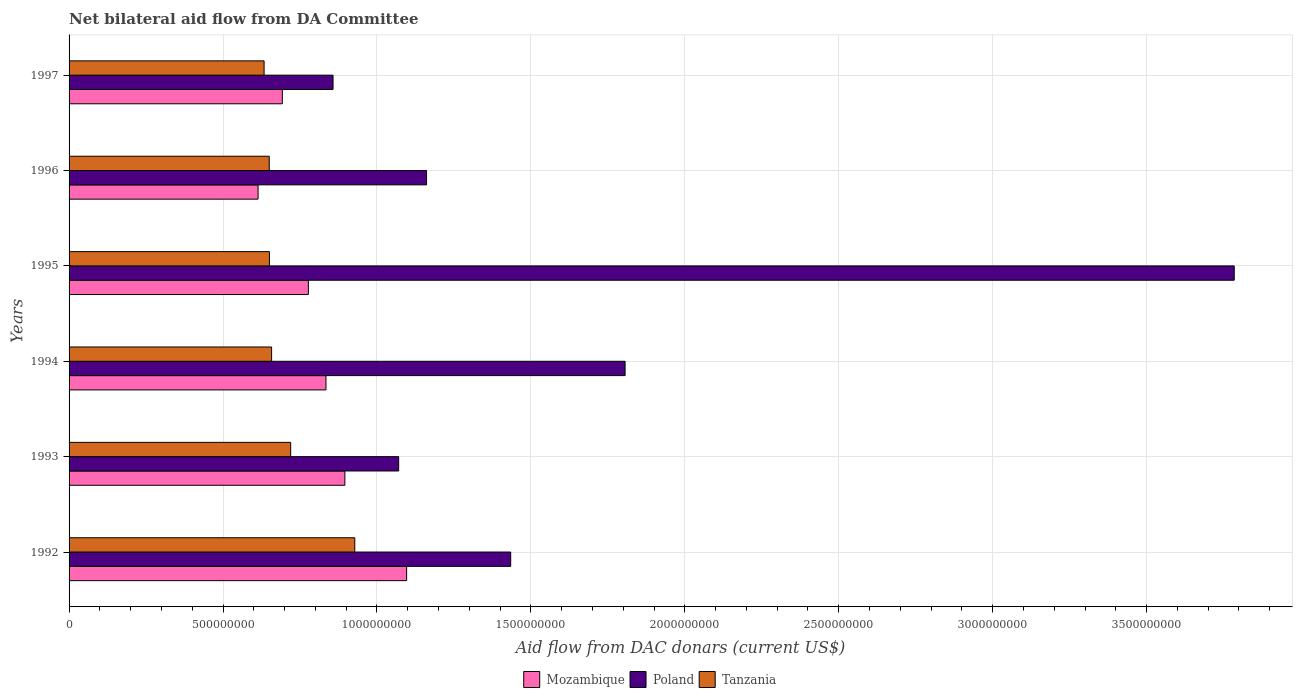Are the number of bars on each tick of the Y-axis equal?
Your answer should be very brief. Yes. How many bars are there on the 6th tick from the top?
Offer a very short reply. 3. What is the aid flow in in Mozambique in 1993?
Your answer should be compact. 8.96e+08. Across all years, what is the maximum aid flow in in Tanzania?
Your answer should be compact. 9.28e+08. Across all years, what is the minimum aid flow in in Mozambique?
Give a very brief answer. 6.14e+08. What is the total aid flow in in Tanzania in the graph?
Offer a very short reply. 4.24e+09. What is the difference between the aid flow in in Poland in 1993 and that in 1996?
Provide a short and direct response. -9.06e+07. What is the difference between the aid flow in in Tanzania in 1996 and the aid flow in in Poland in 1997?
Provide a succinct answer. -2.07e+08. What is the average aid flow in in Tanzania per year?
Keep it short and to the point. 7.07e+08. In the year 1996, what is the difference between the aid flow in in Mozambique and aid flow in in Poland?
Offer a very short reply. -5.47e+08. What is the ratio of the aid flow in in Mozambique in 1992 to that in 1996?
Your response must be concise. 1.79. Is the aid flow in in Mozambique in 1992 less than that in 1995?
Your response must be concise. No. Is the difference between the aid flow in in Mozambique in 1993 and 1995 greater than the difference between the aid flow in in Poland in 1993 and 1995?
Your answer should be compact. Yes. What is the difference between the highest and the second highest aid flow in in Tanzania?
Give a very brief answer. 2.08e+08. What is the difference between the highest and the lowest aid flow in in Mozambique?
Ensure brevity in your answer.  4.83e+08. Is the sum of the aid flow in in Mozambique in 1994 and 1996 greater than the maximum aid flow in in Tanzania across all years?
Offer a very short reply. Yes. What does the 1st bar from the bottom in 1994 represents?
Your answer should be very brief. Mozambique. Is it the case that in every year, the sum of the aid flow in in Mozambique and aid flow in in Tanzania is greater than the aid flow in in Poland?
Your answer should be compact. No. Are all the bars in the graph horizontal?
Make the answer very short. Yes. What is the difference between two consecutive major ticks on the X-axis?
Your response must be concise. 5.00e+08. Are the values on the major ticks of X-axis written in scientific E-notation?
Provide a short and direct response. No. Does the graph contain any zero values?
Make the answer very short. No. Does the graph contain grids?
Offer a very short reply. Yes. How are the legend labels stacked?
Give a very brief answer. Horizontal. What is the title of the graph?
Your answer should be compact. Net bilateral aid flow from DA Committee. Does "Kuwait" appear as one of the legend labels in the graph?
Your answer should be very brief. No. What is the label or title of the X-axis?
Provide a short and direct response. Aid flow from DAC donars (current US$). What is the Aid flow from DAC donars (current US$) in Mozambique in 1992?
Offer a terse response. 1.10e+09. What is the Aid flow from DAC donars (current US$) in Poland in 1992?
Give a very brief answer. 1.43e+09. What is the Aid flow from DAC donars (current US$) of Tanzania in 1992?
Offer a terse response. 9.28e+08. What is the Aid flow from DAC donars (current US$) in Mozambique in 1993?
Offer a very short reply. 8.96e+08. What is the Aid flow from DAC donars (current US$) of Poland in 1993?
Give a very brief answer. 1.07e+09. What is the Aid flow from DAC donars (current US$) in Tanzania in 1993?
Keep it short and to the point. 7.20e+08. What is the Aid flow from DAC donars (current US$) in Mozambique in 1994?
Ensure brevity in your answer.  8.34e+08. What is the Aid flow from DAC donars (current US$) in Poland in 1994?
Your answer should be compact. 1.81e+09. What is the Aid flow from DAC donars (current US$) in Tanzania in 1994?
Give a very brief answer. 6.58e+08. What is the Aid flow from DAC donars (current US$) in Mozambique in 1995?
Ensure brevity in your answer.  7.77e+08. What is the Aid flow from DAC donars (current US$) in Poland in 1995?
Your answer should be compact. 3.78e+09. What is the Aid flow from DAC donars (current US$) in Tanzania in 1995?
Provide a short and direct response. 6.51e+08. What is the Aid flow from DAC donars (current US$) in Mozambique in 1996?
Offer a very short reply. 6.14e+08. What is the Aid flow from DAC donars (current US$) of Poland in 1996?
Your response must be concise. 1.16e+09. What is the Aid flow from DAC donars (current US$) in Tanzania in 1996?
Keep it short and to the point. 6.50e+08. What is the Aid flow from DAC donars (current US$) in Mozambique in 1997?
Your response must be concise. 6.93e+08. What is the Aid flow from DAC donars (current US$) in Poland in 1997?
Offer a terse response. 8.57e+08. What is the Aid flow from DAC donars (current US$) of Tanzania in 1997?
Your answer should be very brief. 6.33e+08. Across all years, what is the maximum Aid flow from DAC donars (current US$) of Mozambique?
Make the answer very short. 1.10e+09. Across all years, what is the maximum Aid flow from DAC donars (current US$) of Poland?
Give a very brief answer. 3.78e+09. Across all years, what is the maximum Aid flow from DAC donars (current US$) in Tanzania?
Give a very brief answer. 9.28e+08. Across all years, what is the minimum Aid flow from DAC donars (current US$) of Mozambique?
Ensure brevity in your answer.  6.14e+08. Across all years, what is the minimum Aid flow from DAC donars (current US$) in Poland?
Make the answer very short. 8.57e+08. Across all years, what is the minimum Aid flow from DAC donars (current US$) of Tanzania?
Ensure brevity in your answer.  6.33e+08. What is the total Aid flow from DAC donars (current US$) of Mozambique in the graph?
Give a very brief answer. 4.91e+09. What is the total Aid flow from DAC donars (current US$) of Poland in the graph?
Your answer should be compact. 1.01e+1. What is the total Aid flow from DAC donars (current US$) in Tanzania in the graph?
Offer a terse response. 4.24e+09. What is the difference between the Aid flow from DAC donars (current US$) of Mozambique in 1992 and that in 1993?
Your response must be concise. 2.01e+08. What is the difference between the Aid flow from DAC donars (current US$) in Poland in 1992 and that in 1993?
Provide a succinct answer. 3.64e+08. What is the difference between the Aid flow from DAC donars (current US$) in Tanzania in 1992 and that in 1993?
Your answer should be compact. 2.08e+08. What is the difference between the Aid flow from DAC donars (current US$) of Mozambique in 1992 and that in 1994?
Your answer should be compact. 2.62e+08. What is the difference between the Aid flow from DAC donars (current US$) of Poland in 1992 and that in 1994?
Your answer should be very brief. -3.72e+08. What is the difference between the Aid flow from DAC donars (current US$) of Tanzania in 1992 and that in 1994?
Your answer should be very brief. 2.70e+08. What is the difference between the Aid flow from DAC donars (current US$) of Mozambique in 1992 and that in 1995?
Keep it short and to the point. 3.19e+08. What is the difference between the Aid flow from DAC donars (current US$) of Poland in 1992 and that in 1995?
Your response must be concise. -2.35e+09. What is the difference between the Aid flow from DAC donars (current US$) of Tanzania in 1992 and that in 1995?
Give a very brief answer. 2.77e+08. What is the difference between the Aid flow from DAC donars (current US$) in Mozambique in 1992 and that in 1996?
Your response must be concise. 4.83e+08. What is the difference between the Aid flow from DAC donars (current US$) in Poland in 1992 and that in 1996?
Provide a short and direct response. 2.73e+08. What is the difference between the Aid flow from DAC donars (current US$) of Tanzania in 1992 and that in 1996?
Your response must be concise. 2.78e+08. What is the difference between the Aid flow from DAC donars (current US$) in Mozambique in 1992 and that in 1997?
Give a very brief answer. 4.04e+08. What is the difference between the Aid flow from DAC donars (current US$) in Poland in 1992 and that in 1997?
Make the answer very short. 5.77e+08. What is the difference between the Aid flow from DAC donars (current US$) in Tanzania in 1992 and that in 1997?
Make the answer very short. 2.95e+08. What is the difference between the Aid flow from DAC donars (current US$) in Mozambique in 1993 and that in 1994?
Ensure brevity in your answer.  6.14e+07. What is the difference between the Aid flow from DAC donars (current US$) of Poland in 1993 and that in 1994?
Offer a terse response. -7.36e+08. What is the difference between the Aid flow from DAC donars (current US$) of Tanzania in 1993 and that in 1994?
Keep it short and to the point. 6.20e+07. What is the difference between the Aid flow from DAC donars (current US$) of Mozambique in 1993 and that in 1995?
Your response must be concise. 1.18e+08. What is the difference between the Aid flow from DAC donars (current US$) in Poland in 1993 and that in 1995?
Your response must be concise. -2.71e+09. What is the difference between the Aid flow from DAC donars (current US$) of Tanzania in 1993 and that in 1995?
Keep it short and to the point. 6.90e+07. What is the difference between the Aid flow from DAC donars (current US$) of Mozambique in 1993 and that in 1996?
Keep it short and to the point. 2.82e+08. What is the difference between the Aid flow from DAC donars (current US$) in Poland in 1993 and that in 1996?
Provide a succinct answer. -9.06e+07. What is the difference between the Aid flow from DAC donars (current US$) in Tanzania in 1993 and that in 1996?
Provide a short and direct response. 6.96e+07. What is the difference between the Aid flow from DAC donars (current US$) of Mozambique in 1993 and that in 1997?
Your answer should be compact. 2.03e+08. What is the difference between the Aid flow from DAC donars (current US$) in Poland in 1993 and that in 1997?
Offer a very short reply. 2.13e+08. What is the difference between the Aid flow from DAC donars (current US$) in Tanzania in 1993 and that in 1997?
Provide a succinct answer. 8.64e+07. What is the difference between the Aid flow from DAC donars (current US$) in Mozambique in 1994 and that in 1995?
Ensure brevity in your answer.  5.72e+07. What is the difference between the Aid flow from DAC donars (current US$) of Poland in 1994 and that in 1995?
Provide a short and direct response. -1.98e+09. What is the difference between the Aid flow from DAC donars (current US$) of Tanzania in 1994 and that in 1995?
Your response must be concise. 7.09e+06. What is the difference between the Aid flow from DAC donars (current US$) in Mozambique in 1994 and that in 1996?
Your answer should be very brief. 2.21e+08. What is the difference between the Aid flow from DAC donars (current US$) in Poland in 1994 and that in 1996?
Provide a succinct answer. 6.45e+08. What is the difference between the Aid flow from DAC donars (current US$) of Tanzania in 1994 and that in 1996?
Keep it short and to the point. 7.66e+06. What is the difference between the Aid flow from DAC donars (current US$) in Mozambique in 1994 and that in 1997?
Your response must be concise. 1.42e+08. What is the difference between the Aid flow from DAC donars (current US$) of Poland in 1994 and that in 1997?
Offer a terse response. 9.49e+08. What is the difference between the Aid flow from DAC donars (current US$) in Tanzania in 1994 and that in 1997?
Offer a very short reply. 2.44e+07. What is the difference between the Aid flow from DAC donars (current US$) of Mozambique in 1995 and that in 1996?
Give a very brief answer. 1.63e+08. What is the difference between the Aid flow from DAC donars (current US$) of Poland in 1995 and that in 1996?
Provide a short and direct response. 2.62e+09. What is the difference between the Aid flow from DAC donars (current US$) in Tanzania in 1995 and that in 1996?
Your response must be concise. 5.70e+05. What is the difference between the Aid flow from DAC donars (current US$) of Mozambique in 1995 and that in 1997?
Provide a short and direct response. 8.46e+07. What is the difference between the Aid flow from DAC donars (current US$) in Poland in 1995 and that in 1997?
Your answer should be very brief. 2.93e+09. What is the difference between the Aid flow from DAC donars (current US$) of Tanzania in 1995 and that in 1997?
Ensure brevity in your answer.  1.73e+07. What is the difference between the Aid flow from DAC donars (current US$) in Mozambique in 1996 and that in 1997?
Offer a very short reply. -7.88e+07. What is the difference between the Aid flow from DAC donars (current US$) in Poland in 1996 and that in 1997?
Provide a short and direct response. 3.04e+08. What is the difference between the Aid flow from DAC donars (current US$) in Tanzania in 1996 and that in 1997?
Provide a short and direct response. 1.68e+07. What is the difference between the Aid flow from DAC donars (current US$) in Mozambique in 1992 and the Aid flow from DAC donars (current US$) in Poland in 1993?
Make the answer very short. 2.58e+07. What is the difference between the Aid flow from DAC donars (current US$) of Mozambique in 1992 and the Aid flow from DAC donars (current US$) of Tanzania in 1993?
Offer a very short reply. 3.77e+08. What is the difference between the Aid flow from DAC donars (current US$) of Poland in 1992 and the Aid flow from DAC donars (current US$) of Tanzania in 1993?
Provide a succinct answer. 7.15e+08. What is the difference between the Aid flow from DAC donars (current US$) of Mozambique in 1992 and the Aid flow from DAC donars (current US$) of Poland in 1994?
Provide a succinct answer. -7.10e+08. What is the difference between the Aid flow from DAC donars (current US$) of Mozambique in 1992 and the Aid flow from DAC donars (current US$) of Tanzania in 1994?
Make the answer very short. 4.39e+08. What is the difference between the Aid flow from DAC donars (current US$) in Poland in 1992 and the Aid flow from DAC donars (current US$) in Tanzania in 1994?
Provide a succinct answer. 7.77e+08. What is the difference between the Aid flow from DAC donars (current US$) of Mozambique in 1992 and the Aid flow from DAC donars (current US$) of Poland in 1995?
Your answer should be very brief. -2.69e+09. What is the difference between the Aid flow from DAC donars (current US$) in Mozambique in 1992 and the Aid flow from DAC donars (current US$) in Tanzania in 1995?
Give a very brief answer. 4.46e+08. What is the difference between the Aid flow from DAC donars (current US$) of Poland in 1992 and the Aid flow from DAC donars (current US$) of Tanzania in 1995?
Ensure brevity in your answer.  7.84e+08. What is the difference between the Aid flow from DAC donars (current US$) in Mozambique in 1992 and the Aid flow from DAC donars (current US$) in Poland in 1996?
Make the answer very short. -6.47e+07. What is the difference between the Aid flow from DAC donars (current US$) in Mozambique in 1992 and the Aid flow from DAC donars (current US$) in Tanzania in 1996?
Ensure brevity in your answer.  4.46e+08. What is the difference between the Aid flow from DAC donars (current US$) in Poland in 1992 and the Aid flow from DAC donars (current US$) in Tanzania in 1996?
Keep it short and to the point. 7.84e+08. What is the difference between the Aid flow from DAC donars (current US$) of Mozambique in 1992 and the Aid flow from DAC donars (current US$) of Poland in 1997?
Provide a succinct answer. 2.39e+08. What is the difference between the Aid flow from DAC donars (current US$) in Mozambique in 1992 and the Aid flow from DAC donars (current US$) in Tanzania in 1997?
Provide a short and direct response. 4.63e+08. What is the difference between the Aid flow from DAC donars (current US$) in Poland in 1992 and the Aid flow from DAC donars (current US$) in Tanzania in 1997?
Give a very brief answer. 8.01e+08. What is the difference between the Aid flow from DAC donars (current US$) in Mozambique in 1993 and the Aid flow from DAC donars (current US$) in Poland in 1994?
Give a very brief answer. -9.10e+08. What is the difference between the Aid flow from DAC donars (current US$) of Mozambique in 1993 and the Aid flow from DAC donars (current US$) of Tanzania in 1994?
Provide a short and direct response. 2.38e+08. What is the difference between the Aid flow from DAC donars (current US$) of Poland in 1993 and the Aid flow from DAC donars (current US$) of Tanzania in 1994?
Provide a short and direct response. 4.13e+08. What is the difference between the Aid flow from DAC donars (current US$) in Mozambique in 1993 and the Aid flow from DAC donars (current US$) in Poland in 1995?
Your response must be concise. -2.89e+09. What is the difference between the Aid flow from DAC donars (current US$) in Mozambique in 1993 and the Aid flow from DAC donars (current US$) in Tanzania in 1995?
Give a very brief answer. 2.45e+08. What is the difference between the Aid flow from DAC donars (current US$) in Poland in 1993 and the Aid flow from DAC donars (current US$) in Tanzania in 1995?
Provide a succinct answer. 4.20e+08. What is the difference between the Aid flow from DAC donars (current US$) of Mozambique in 1993 and the Aid flow from DAC donars (current US$) of Poland in 1996?
Offer a very short reply. -2.65e+08. What is the difference between the Aid flow from DAC donars (current US$) of Mozambique in 1993 and the Aid flow from DAC donars (current US$) of Tanzania in 1996?
Provide a short and direct response. 2.46e+08. What is the difference between the Aid flow from DAC donars (current US$) in Poland in 1993 and the Aid flow from DAC donars (current US$) in Tanzania in 1996?
Your answer should be compact. 4.20e+08. What is the difference between the Aid flow from DAC donars (current US$) in Mozambique in 1993 and the Aid flow from DAC donars (current US$) in Poland in 1997?
Ensure brevity in your answer.  3.84e+07. What is the difference between the Aid flow from DAC donars (current US$) of Mozambique in 1993 and the Aid flow from DAC donars (current US$) of Tanzania in 1997?
Ensure brevity in your answer.  2.62e+08. What is the difference between the Aid flow from DAC donars (current US$) of Poland in 1993 and the Aid flow from DAC donars (current US$) of Tanzania in 1997?
Provide a succinct answer. 4.37e+08. What is the difference between the Aid flow from DAC donars (current US$) of Mozambique in 1994 and the Aid flow from DAC donars (current US$) of Poland in 1995?
Give a very brief answer. -2.95e+09. What is the difference between the Aid flow from DAC donars (current US$) in Mozambique in 1994 and the Aid flow from DAC donars (current US$) in Tanzania in 1995?
Offer a very short reply. 1.84e+08. What is the difference between the Aid flow from DAC donars (current US$) in Poland in 1994 and the Aid flow from DAC donars (current US$) in Tanzania in 1995?
Your answer should be compact. 1.16e+09. What is the difference between the Aid flow from DAC donars (current US$) of Mozambique in 1994 and the Aid flow from DAC donars (current US$) of Poland in 1996?
Give a very brief answer. -3.27e+08. What is the difference between the Aid flow from DAC donars (current US$) in Mozambique in 1994 and the Aid flow from DAC donars (current US$) in Tanzania in 1996?
Keep it short and to the point. 1.84e+08. What is the difference between the Aid flow from DAC donars (current US$) in Poland in 1994 and the Aid flow from DAC donars (current US$) in Tanzania in 1996?
Your answer should be very brief. 1.16e+09. What is the difference between the Aid flow from DAC donars (current US$) in Mozambique in 1994 and the Aid flow from DAC donars (current US$) in Poland in 1997?
Your response must be concise. -2.30e+07. What is the difference between the Aid flow from DAC donars (current US$) in Mozambique in 1994 and the Aid flow from DAC donars (current US$) in Tanzania in 1997?
Give a very brief answer. 2.01e+08. What is the difference between the Aid flow from DAC donars (current US$) of Poland in 1994 and the Aid flow from DAC donars (current US$) of Tanzania in 1997?
Your response must be concise. 1.17e+09. What is the difference between the Aid flow from DAC donars (current US$) of Mozambique in 1995 and the Aid flow from DAC donars (current US$) of Poland in 1996?
Offer a very short reply. -3.84e+08. What is the difference between the Aid flow from DAC donars (current US$) in Mozambique in 1995 and the Aid flow from DAC donars (current US$) in Tanzania in 1996?
Keep it short and to the point. 1.27e+08. What is the difference between the Aid flow from DAC donars (current US$) of Poland in 1995 and the Aid flow from DAC donars (current US$) of Tanzania in 1996?
Offer a terse response. 3.13e+09. What is the difference between the Aid flow from DAC donars (current US$) of Mozambique in 1995 and the Aid flow from DAC donars (current US$) of Poland in 1997?
Provide a short and direct response. -8.01e+07. What is the difference between the Aid flow from DAC donars (current US$) in Mozambique in 1995 and the Aid flow from DAC donars (current US$) in Tanzania in 1997?
Your response must be concise. 1.44e+08. What is the difference between the Aid flow from DAC donars (current US$) in Poland in 1995 and the Aid flow from DAC donars (current US$) in Tanzania in 1997?
Give a very brief answer. 3.15e+09. What is the difference between the Aid flow from DAC donars (current US$) in Mozambique in 1996 and the Aid flow from DAC donars (current US$) in Poland in 1997?
Offer a terse response. -2.44e+08. What is the difference between the Aid flow from DAC donars (current US$) in Mozambique in 1996 and the Aid flow from DAC donars (current US$) in Tanzania in 1997?
Provide a succinct answer. -1.95e+07. What is the difference between the Aid flow from DAC donars (current US$) in Poland in 1996 and the Aid flow from DAC donars (current US$) in Tanzania in 1997?
Provide a succinct answer. 5.28e+08. What is the average Aid flow from DAC donars (current US$) in Mozambique per year?
Make the answer very short. 8.18e+08. What is the average Aid flow from DAC donars (current US$) of Poland per year?
Make the answer very short. 1.69e+09. What is the average Aid flow from DAC donars (current US$) of Tanzania per year?
Keep it short and to the point. 7.07e+08. In the year 1992, what is the difference between the Aid flow from DAC donars (current US$) in Mozambique and Aid flow from DAC donars (current US$) in Poland?
Make the answer very short. -3.38e+08. In the year 1992, what is the difference between the Aid flow from DAC donars (current US$) in Mozambique and Aid flow from DAC donars (current US$) in Tanzania?
Provide a short and direct response. 1.68e+08. In the year 1992, what is the difference between the Aid flow from DAC donars (current US$) in Poland and Aid flow from DAC donars (current US$) in Tanzania?
Provide a short and direct response. 5.06e+08. In the year 1993, what is the difference between the Aid flow from DAC donars (current US$) in Mozambique and Aid flow from DAC donars (current US$) in Poland?
Ensure brevity in your answer.  -1.75e+08. In the year 1993, what is the difference between the Aid flow from DAC donars (current US$) of Mozambique and Aid flow from DAC donars (current US$) of Tanzania?
Give a very brief answer. 1.76e+08. In the year 1993, what is the difference between the Aid flow from DAC donars (current US$) in Poland and Aid flow from DAC donars (current US$) in Tanzania?
Provide a succinct answer. 3.51e+08. In the year 1994, what is the difference between the Aid flow from DAC donars (current US$) of Mozambique and Aid flow from DAC donars (current US$) of Poland?
Ensure brevity in your answer.  -9.72e+08. In the year 1994, what is the difference between the Aid flow from DAC donars (current US$) in Mozambique and Aid flow from DAC donars (current US$) in Tanzania?
Offer a very short reply. 1.77e+08. In the year 1994, what is the difference between the Aid flow from DAC donars (current US$) in Poland and Aid flow from DAC donars (current US$) in Tanzania?
Make the answer very short. 1.15e+09. In the year 1995, what is the difference between the Aid flow from DAC donars (current US$) in Mozambique and Aid flow from DAC donars (current US$) in Poland?
Your response must be concise. -3.01e+09. In the year 1995, what is the difference between the Aid flow from DAC donars (current US$) of Mozambique and Aid flow from DAC donars (current US$) of Tanzania?
Your answer should be compact. 1.27e+08. In the year 1995, what is the difference between the Aid flow from DAC donars (current US$) in Poland and Aid flow from DAC donars (current US$) in Tanzania?
Offer a terse response. 3.13e+09. In the year 1996, what is the difference between the Aid flow from DAC donars (current US$) of Mozambique and Aid flow from DAC donars (current US$) of Poland?
Offer a terse response. -5.47e+08. In the year 1996, what is the difference between the Aid flow from DAC donars (current US$) in Mozambique and Aid flow from DAC donars (current US$) in Tanzania?
Offer a very short reply. -3.63e+07. In the year 1996, what is the difference between the Aid flow from DAC donars (current US$) in Poland and Aid flow from DAC donars (current US$) in Tanzania?
Offer a very short reply. 5.11e+08. In the year 1997, what is the difference between the Aid flow from DAC donars (current US$) in Mozambique and Aid flow from DAC donars (current US$) in Poland?
Provide a short and direct response. -1.65e+08. In the year 1997, what is the difference between the Aid flow from DAC donars (current US$) of Mozambique and Aid flow from DAC donars (current US$) of Tanzania?
Your response must be concise. 5.92e+07. In the year 1997, what is the difference between the Aid flow from DAC donars (current US$) of Poland and Aid flow from DAC donars (current US$) of Tanzania?
Give a very brief answer. 2.24e+08. What is the ratio of the Aid flow from DAC donars (current US$) of Mozambique in 1992 to that in 1993?
Your answer should be very brief. 1.22. What is the ratio of the Aid flow from DAC donars (current US$) of Poland in 1992 to that in 1993?
Keep it short and to the point. 1.34. What is the ratio of the Aid flow from DAC donars (current US$) in Tanzania in 1992 to that in 1993?
Give a very brief answer. 1.29. What is the ratio of the Aid flow from DAC donars (current US$) in Mozambique in 1992 to that in 1994?
Provide a short and direct response. 1.31. What is the ratio of the Aid flow from DAC donars (current US$) in Poland in 1992 to that in 1994?
Keep it short and to the point. 0.79. What is the ratio of the Aid flow from DAC donars (current US$) in Tanzania in 1992 to that in 1994?
Give a very brief answer. 1.41. What is the ratio of the Aid flow from DAC donars (current US$) of Mozambique in 1992 to that in 1995?
Keep it short and to the point. 1.41. What is the ratio of the Aid flow from DAC donars (current US$) of Poland in 1992 to that in 1995?
Provide a short and direct response. 0.38. What is the ratio of the Aid flow from DAC donars (current US$) of Tanzania in 1992 to that in 1995?
Provide a succinct answer. 1.43. What is the ratio of the Aid flow from DAC donars (current US$) in Mozambique in 1992 to that in 1996?
Your answer should be very brief. 1.79. What is the ratio of the Aid flow from DAC donars (current US$) in Poland in 1992 to that in 1996?
Make the answer very short. 1.24. What is the ratio of the Aid flow from DAC donars (current US$) of Tanzania in 1992 to that in 1996?
Ensure brevity in your answer.  1.43. What is the ratio of the Aid flow from DAC donars (current US$) in Mozambique in 1992 to that in 1997?
Offer a very short reply. 1.58. What is the ratio of the Aid flow from DAC donars (current US$) of Poland in 1992 to that in 1997?
Provide a succinct answer. 1.67. What is the ratio of the Aid flow from DAC donars (current US$) in Tanzania in 1992 to that in 1997?
Provide a short and direct response. 1.47. What is the ratio of the Aid flow from DAC donars (current US$) of Mozambique in 1993 to that in 1994?
Your response must be concise. 1.07. What is the ratio of the Aid flow from DAC donars (current US$) of Poland in 1993 to that in 1994?
Ensure brevity in your answer.  0.59. What is the ratio of the Aid flow from DAC donars (current US$) in Tanzania in 1993 to that in 1994?
Keep it short and to the point. 1.09. What is the ratio of the Aid flow from DAC donars (current US$) in Mozambique in 1993 to that in 1995?
Your response must be concise. 1.15. What is the ratio of the Aid flow from DAC donars (current US$) of Poland in 1993 to that in 1995?
Provide a succinct answer. 0.28. What is the ratio of the Aid flow from DAC donars (current US$) of Tanzania in 1993 to that in 1995?
Ensure brevity in your answer.  1.11. What is the ratio of the Aid flow from DAC donars (current US$) in Mozambique in 1993 to that in 1996?
Provide a succinct answer. 1.46. What is the ratio of the Aid flow from DAC donars (current US$) in Poland in 1993 to that in 1996?
Provide a short and direct response. 0.92. What is the ratio of the Aid flow from DAC donars (current US$) in Tanzania in 1993 to that in 1996?
Your answer should be compact. 1.11. What is the ratio of the Aid flow from DAC donars (current US$) of Mozambique in 1993 to that in 1997?
Your answer should be very brief. 1.29. What is the ratio of the Aid flow from DAC donars (current US$) of Poland in 1993 to that in 1997?
Keep it short and to the point. 1.25. What is the ratio of the Aid flow from DAC donars (current US$) of Tanzania in 1993 to that in 1997?
Your answer should be very brief. 1.14. What is the ratio of the Aid flow from DAC donars (current US$) of Mozambique in 1994 to that in 1995?
Your answer should be very brief. 1.07. What is the ratio of the Aid flow from DAC donars (current US$) of Poland in 1994 to that in 1995?
Your response must be concise. 0.48. What is the ratio of the Aid flow from DAC donars (current US$) of Tanzania in 1994 to that in 1995?
Your answer should be compact. 1.01. What is the ratio of the Aid flow from DAC donars (current US$) of Mozambique in 1994 to that in 1996?
Make the answer very short. 1.36. What is the ratio of the Aid flow from DAC donars (current US$) of Poland in 1994 to that in 1996?
Provide a succinct answer. 1.56. What is the ratio of the Aid flow from DAC donars (current US$) in Tanzania in 1994 to that in 1996?
Provide a short and direct response. 1.01. What is the ratio of the Aid flow from DAC donars (current US$) in Mozambique in 1994 to that in 1997?
Provide a short and direct response. 1.2. What is the ratio of the Aid flow from DAC donars (current US$) in Poland in 1994 to that in 1997?
Provide a succinct answer. 2.11. What is the ratio of the Aid flow from DAC donars (current US$) in Tanzania in 1994 to that in 1997?
Your answer should be compact. 1.04. What is the ratio of the Aid flow from DAC donars (current US$) of Mozambique in 1995 to that in 1996?
Offer a terse response. 1.27. What is the ratio of the Aid flow from DAC donars (current US$) in Poland in 1995 to that in 1996?
Ensure brevity in your answer.  3.26. What is the ratio of the Aid flow from DAC donars (current US$) in Mozambique in 1995 to that in 1997?
Your answer should be very brief. 1.12. What is the ratio of the Aid flow from DAC donars (current US$) of Poland in 1995 to that in 1997?
Provide a succinct answer. 4.41. What is the ratio of the Aid flow from DAC donars (current US$) of Tanzania in 1995 to that in 1997?
Keep it short and to the point. 1.03. What is the ratio of the Aid flow from DAC donars (current US$) in Mozambique in 1996 to that in 1997?
Your answer should be very brief. 0.89. What is the ratio of the Aid flow from DAC donars (current US$) of Poland in 1996 to that in 1997?
Give a very brief answer. 1.35. What is the ratio of the Aid flow from DAC donars (current US$) of Tanzania in 1996 to that in 1997?
Give a very brief answer. 1.03. What is the difference between the highest and the second highest Aid flow from DAC donars (current US$) of Mozambique?
Your answer should be compact. 2.01e+08. What is the difference between the highest and the second highest Aid flow from DAC donars (current US$) of Poland?
Your response must be concise. 1.98e+09. What is the difference between the highest and the second highest Aid flow from DAC donars (current US$) of Tanzania?
Your answer should be very brief. 2.08e+08. What is the difference between the highest and the lowest Aid flow from DAC donars (current US$) of Mozambique?
Your answer should be very brief. 4.83e+08. What is the difference between the highest and the lowest Aid flow from DAC donars (current US$) in Poland?
Offer a very short reply. 2.93e+09. What is the difference between the highest and the lowest Aid flow from DAC donars (current US$) of Tanzania?
Offer a very short reply. 2.95e+08. 